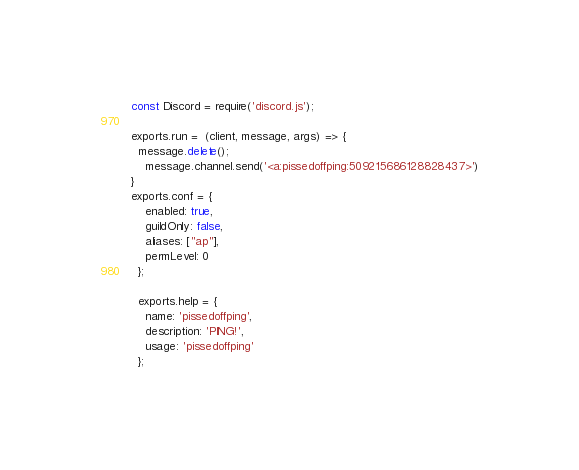Convert code to text. <code><loc_0><loc_0><loc_500><loc_500><_JavaScript_>const Discord = require('discord.js');

exports.run =  (client, message, args) => {
  message.delete();
    message.channel.send('<a:pissedoffping:509215686128828437>')
}
exports.conf = {
    enabled: true,
    guildOnly: false,
    aliases: ["ap"],
    permLevel: 0
  };
  
  exports.help = {
    name: 'pissedoffping',
    description: 'PING!',
    usage: 'pissedoffping'
  };</code> 